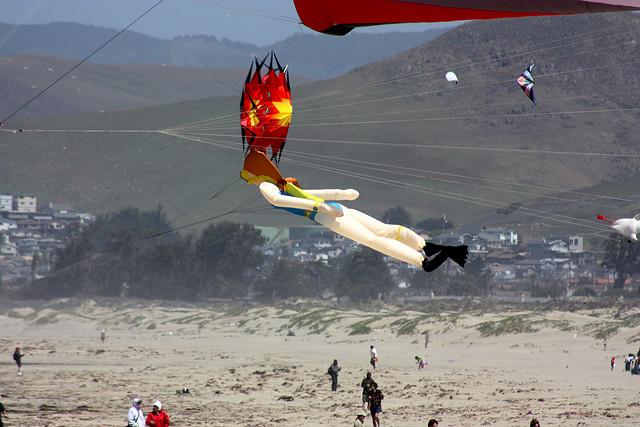Can you describe the background details of the image? In the background of the image, there are serene, rolling hills that extend horizontally across the scene. The hills are covered in muted tones of green and brown, likely indicative of sparse vegetation. At the base of these hills lies a town with a variety of buildings. The structures appear to be residential, characterized by their modest height and varying designs. The town is bordered by a line of trees, which slightly obscure the lower portions of the buildings. The entire backdrop provides a calm, picturesque setting for the lively beach scene in the foreground. 